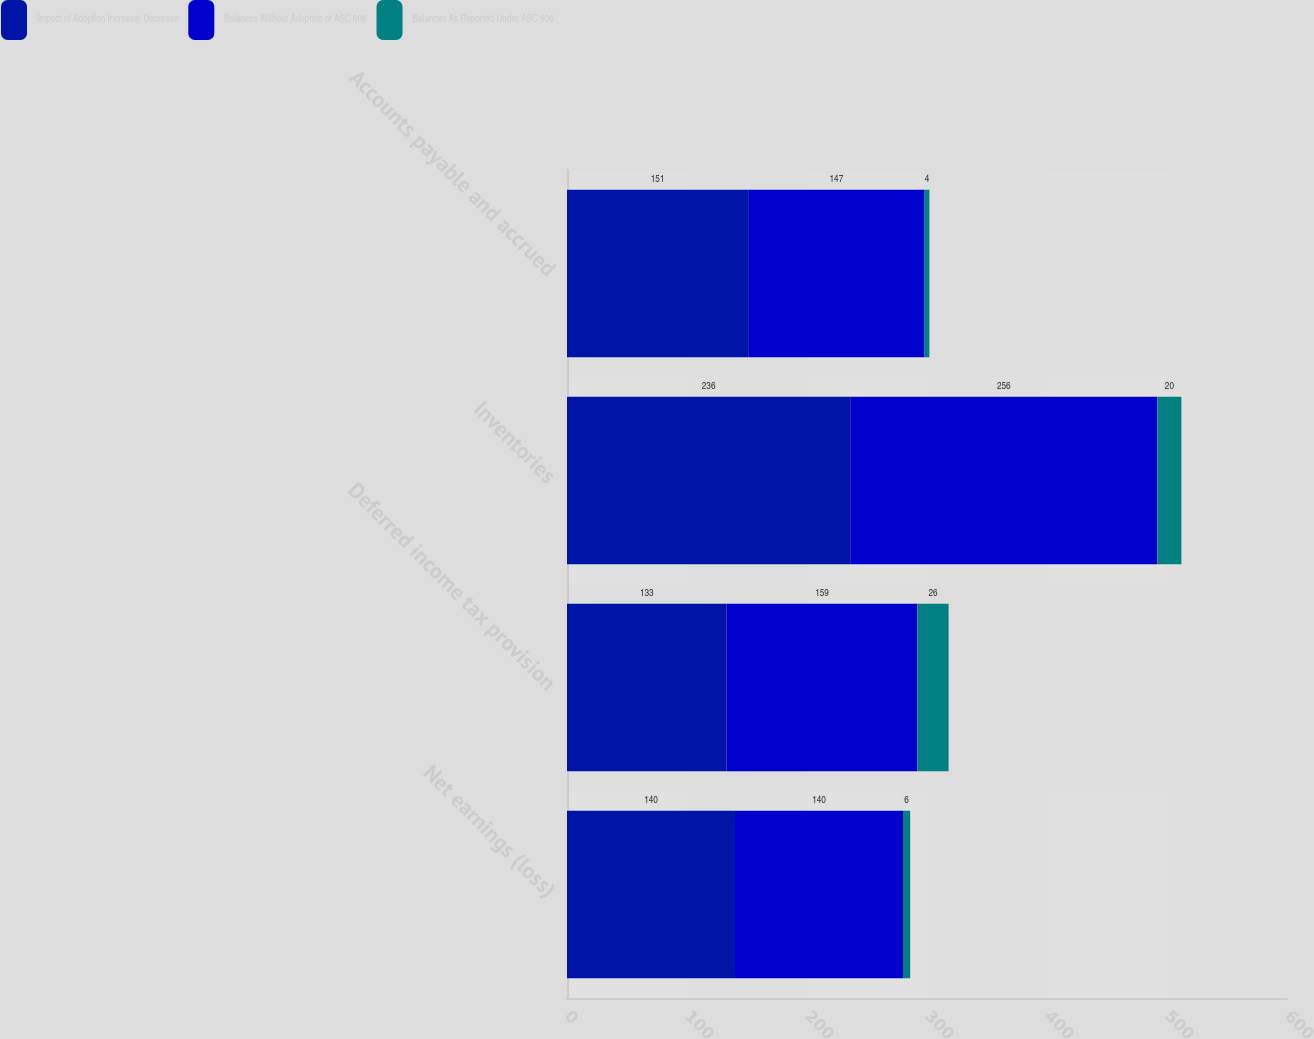Convert chart. <chart><loc_0><loc_0><loc_500><loc_500><stacked_bar_chart><ecel><fcel>Net earnings (loss)<fcel>Deferred income tax provision<fcel>Inventories<fcel>Accounts payable and accrued<nl><fcel>Impact of Adoption Increase/ Decrease<fcel>140<fcel>133<fcel>236<fcel>151<nl><fcel>Balances Without Adoption of ASC 606<fcel>140<fcel>159<fcel>256<fcel>147<nl><fcel>Balances As Reported Under ASC 606<fcel>6<fcel>26<fcel>20<fcel>4<nl></chart> 